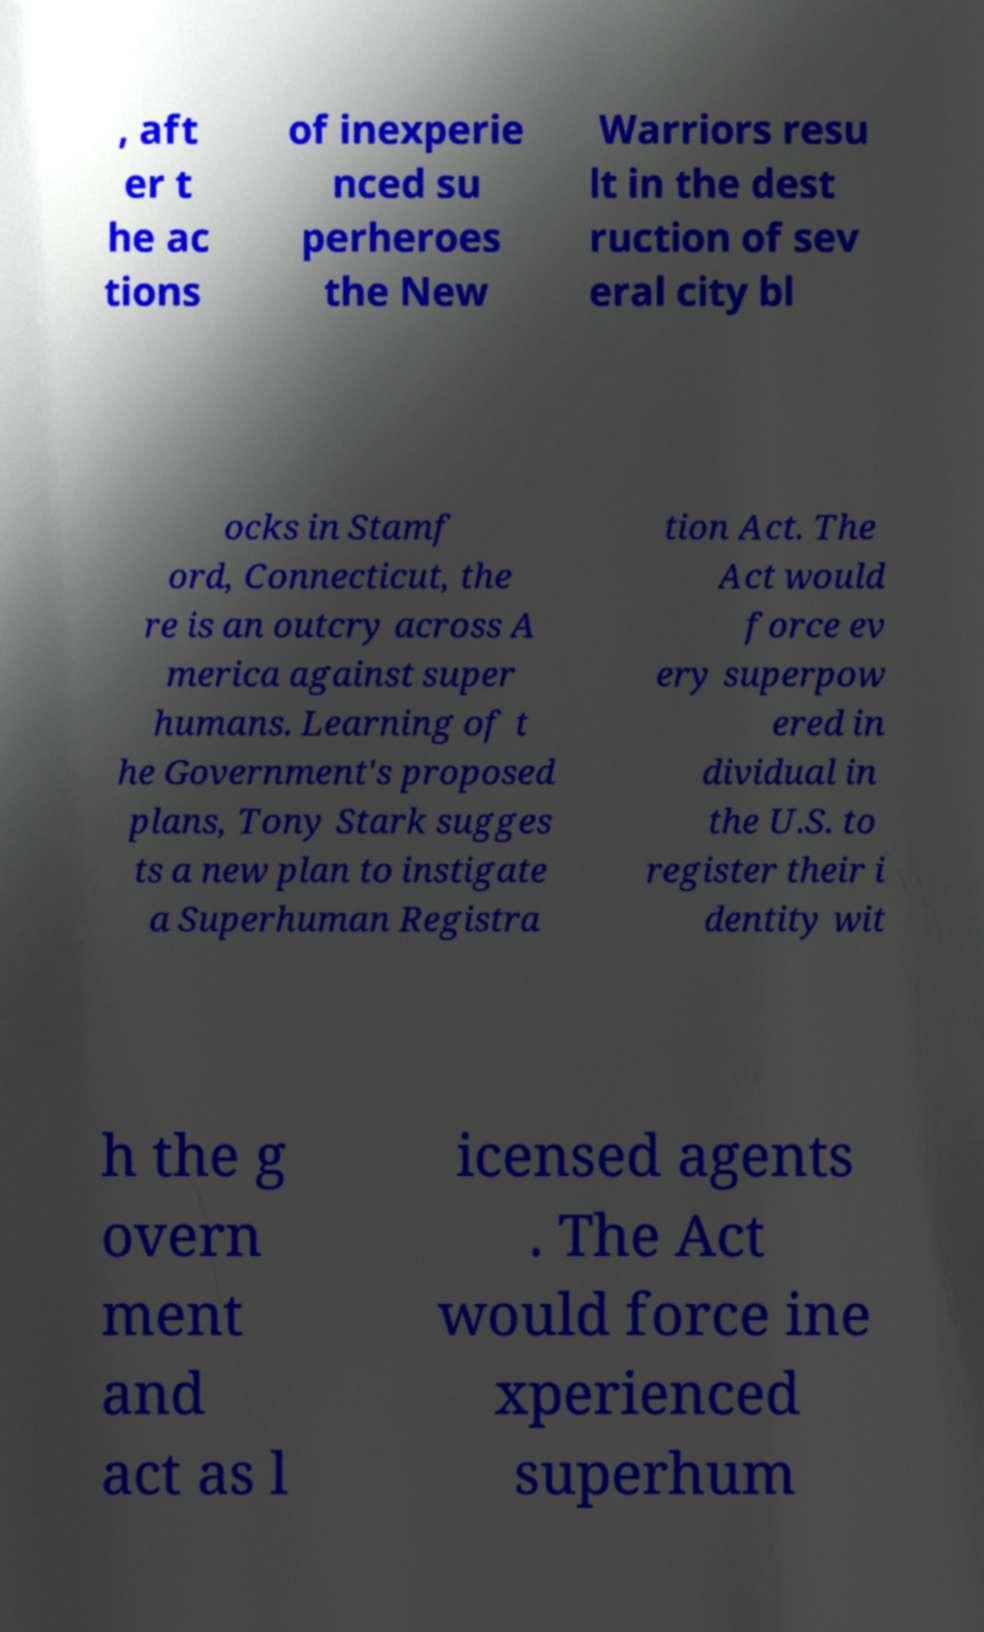Can you accurately transcribe the text from the provided image for me? , aft er t he ac tions of inexperie nced su perheroes the New Warriors resu lt in the dest ruction of sev eral city bl ocks in Stamf ord, Connecticut, the re is an outcry across A merica against super humans. Learning of t he Government's proposed plans, Tony Stark sugges ts a new plan to instigate a Superhuman Registra tion Act. The Act would force ev ery superpow ered in dividual in the U.S. to register their i dentity wit h the g overn ment and act as l icensed agents . The Act would force ine xperienced superhum 